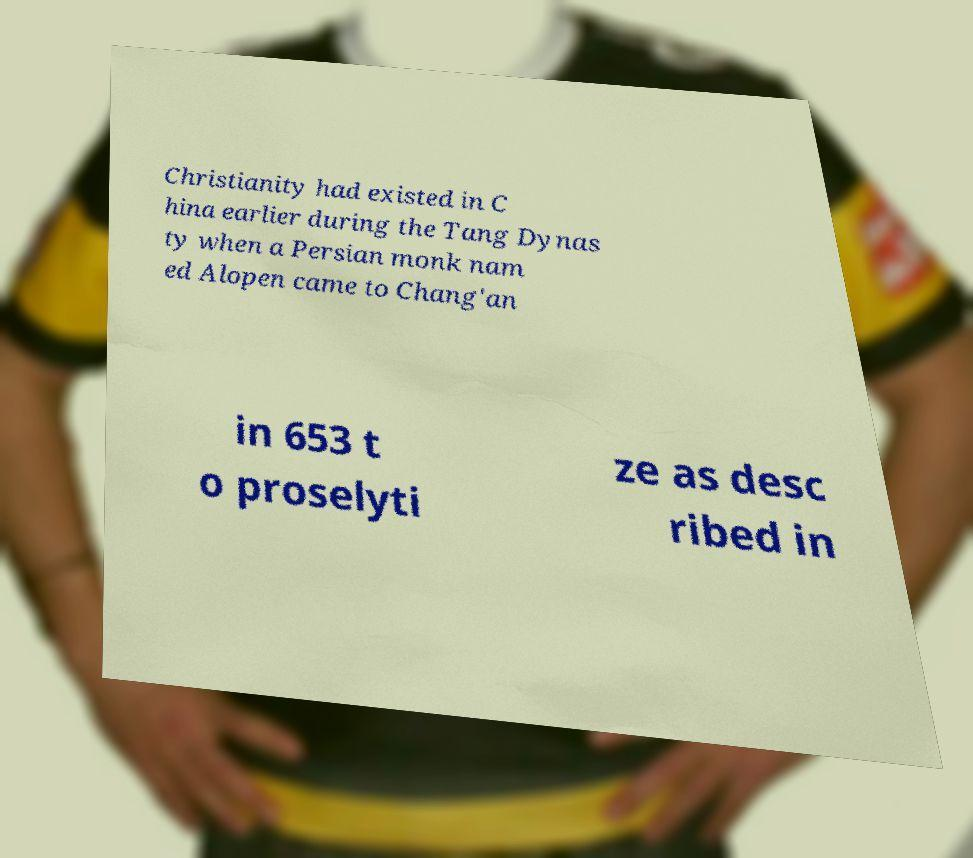What messages or text are displayed in this image? I need them in a readable, typed format. Christianity had existed in C hina earlier during the Tang Dynas ty when a Persian monk nam ed Alopen came to Chang'an in 653 t o proselyti ze as desc ribed in 